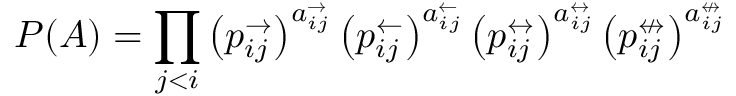<formula> <loc_0><loc_0><loc_500><loc_500>P ( A ) = \prod _ { j < i } \left ( p _ { i j } ^ { \rightarrow } \right ) ^ { a _ { i j } ^ { \rightarrow } } \left ( p _ { i j } ^ { \leftarrow } \right ) ^ { a _ { i j } ^ { \leftarrow } } \left ( p _ { i j } ^ { \leftrightarrow } \right ) ^ { a _ { i j } ^ { \leftrightarrow } } \left ( p _ { i j } ^ { \ n l e f t r i g h t a r r o w } \right ) ^ { a _ { i j } ^ { \ n l e f t r i g h t a r r o w } }</formula> 